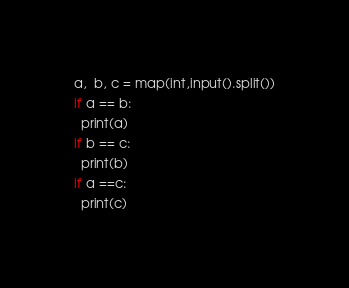<code> <loc_0><loc_0><loc_500><loc_500><_Python_>a,  b, c = map(int,input().split())
if a == b:
  print(a)
if b == c:
  print(b)
if a ==c:
  print(c)</code> 